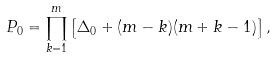<formula> <loc_0><loc_0><loc_500><loc_500>P _ { 0 } = \prod _ { k = 1 } ^ { m } \left [ \Delta _ { 0 } + ( m - k ) ( m + k - 1 ) \right ] ,</formula> 